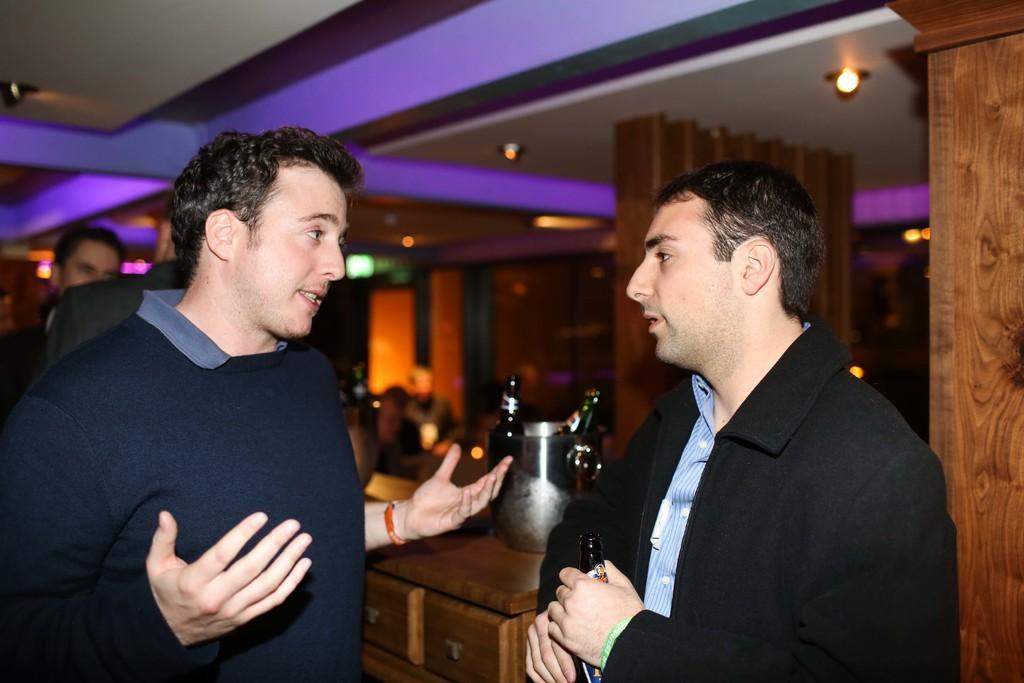In one or two sentences, can you explain what this image depicts? In this image on the right side, I can see a person holding a glass bottle. On the left side I can see some people. At the I can see the lights. 